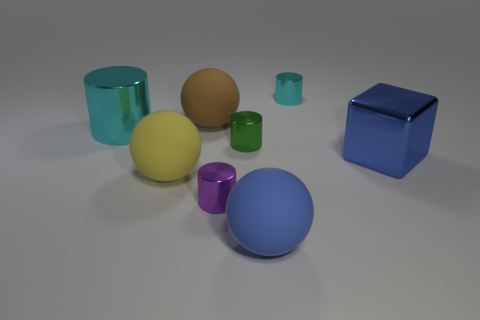Does the metallic block have the same color as the thing that is in front of the tiny purple object?
Provide a succinct answer. Yes. What is the shape of the big rubber thing that is the same color as the large cube?
Give a very brief answer. Sphere. What number of big cyan objects are in front of the blue metallic cube?
Your response must be concise. 0. What size is the rubber ball behind the thing that is on the left side of the ball left of the big brown ball?
Provide a short and direct response. Large. There is a small cyan shiny thing; is its shape the same as the cyan thing to the left of the tiny purple cylinder?
Ensure brevity in your answer.  Yes. There is a blue object that is made of the same material as the purple object; what size is it?
Keep it short and to the point. Large. Is there any other thing that has the same color as the big metallic cylinder?
Provide a succinct answer. Yes. There is a ball behind the cyan metallic cylinder in front of the cyan metal cylinder that is on the right side of the green metal cylinder; what is it made of?
Provide a short and direct response. Rubber. How many rubber objects are big yellow cylinders or things?
Your response must be concise. 3. How many things are large brown things or large rubber balls that are in front of the large blue block?
Your answer should be very brief. 3. 